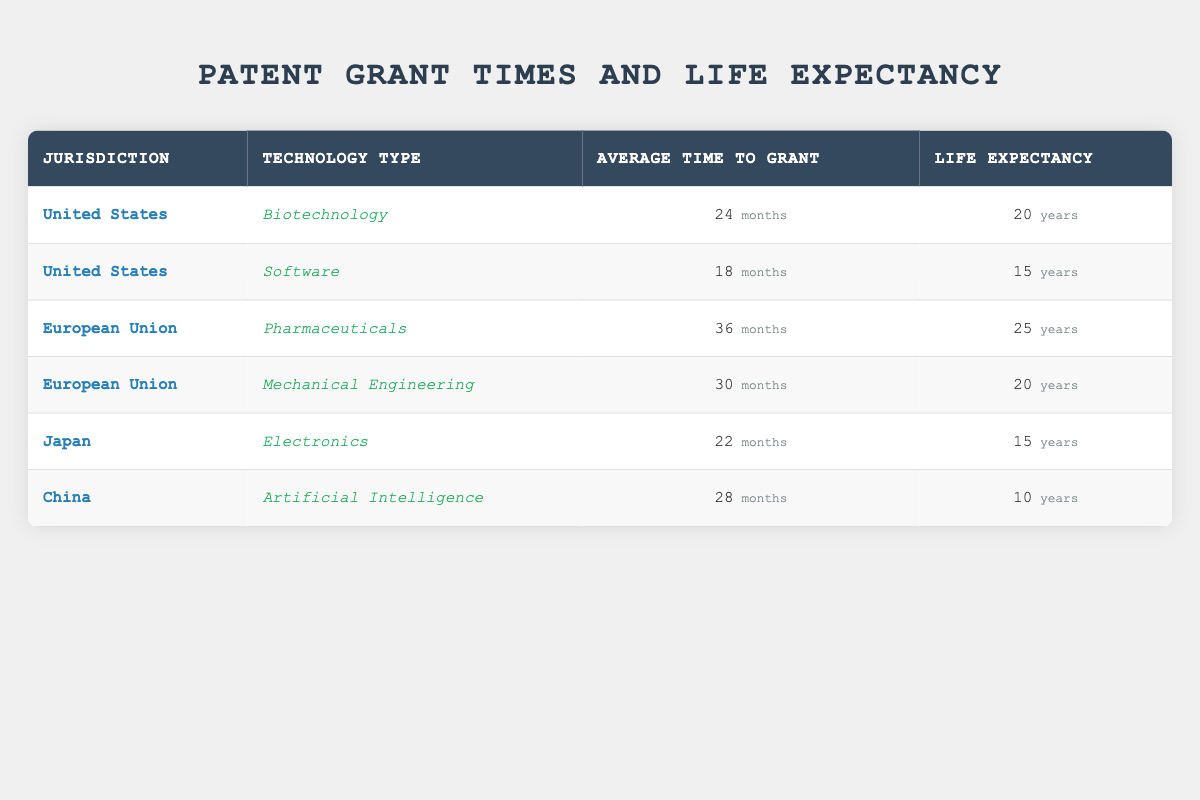What is the average time to grant a patent in the United States for Biotechnology? The table lists the average time to grant a patent for Biotechnology in the United States as 24 months.
Answer: 24 months Which jurisdiction has the shortest average time to grant a patent for Software? In the table, the United States has an average time to grant a patent for Software listed as 18 months, which is the shortest compared to other jurisdictions.
Answer: United States How many years is the life expectancy for patents in the European Union for Pharmaceuticals? According to the table, the life expectancy for patents in the European Union for Pharmaceuticals is 25 years.
Answer: 25 years What is the difference in average time to grant patents between the European Union for Pharmaceuticals and Japan for Electronics? The average time to grant a patent in the European Union for Pharmaceuticals is 36 months and in Japan for Electronics is 22 months; the difference is 36 - 22 = 14 months.
Answer: 14 months Is the life expectancy of patents for AI in China greater than the life expectancy for biotechnology patents in the United States? The life expectancy of patents for AI in China is 10 years, while for biotechnology in the United States it is 20 years; thus, the statement is false.
Answer: No Which technology type has the longest average time to grant a patent, and which jurisdiction does it belong to? The table shows that Pharmaceuticals in the European Union has the longest average time to grant a patent at 36 months.
Answer: Pharmaceuticals in European Union If you add the life expectancy of patents for Software in the United States and Electronics in Japan, what is the total? The life expectancy for Software in the United States is 15 years and for Electronics in Japan is also 15 years; adding them gives 15 + 15 = 30 years.
Answer: 30 years Which jurisdiction has a life expectancy of patents that is lower than 15 years? The table indicates that the only jurisdiction with a life expectancy lower than 15 years is China with 10 years for Artificial Intelligence.
Answer: China 